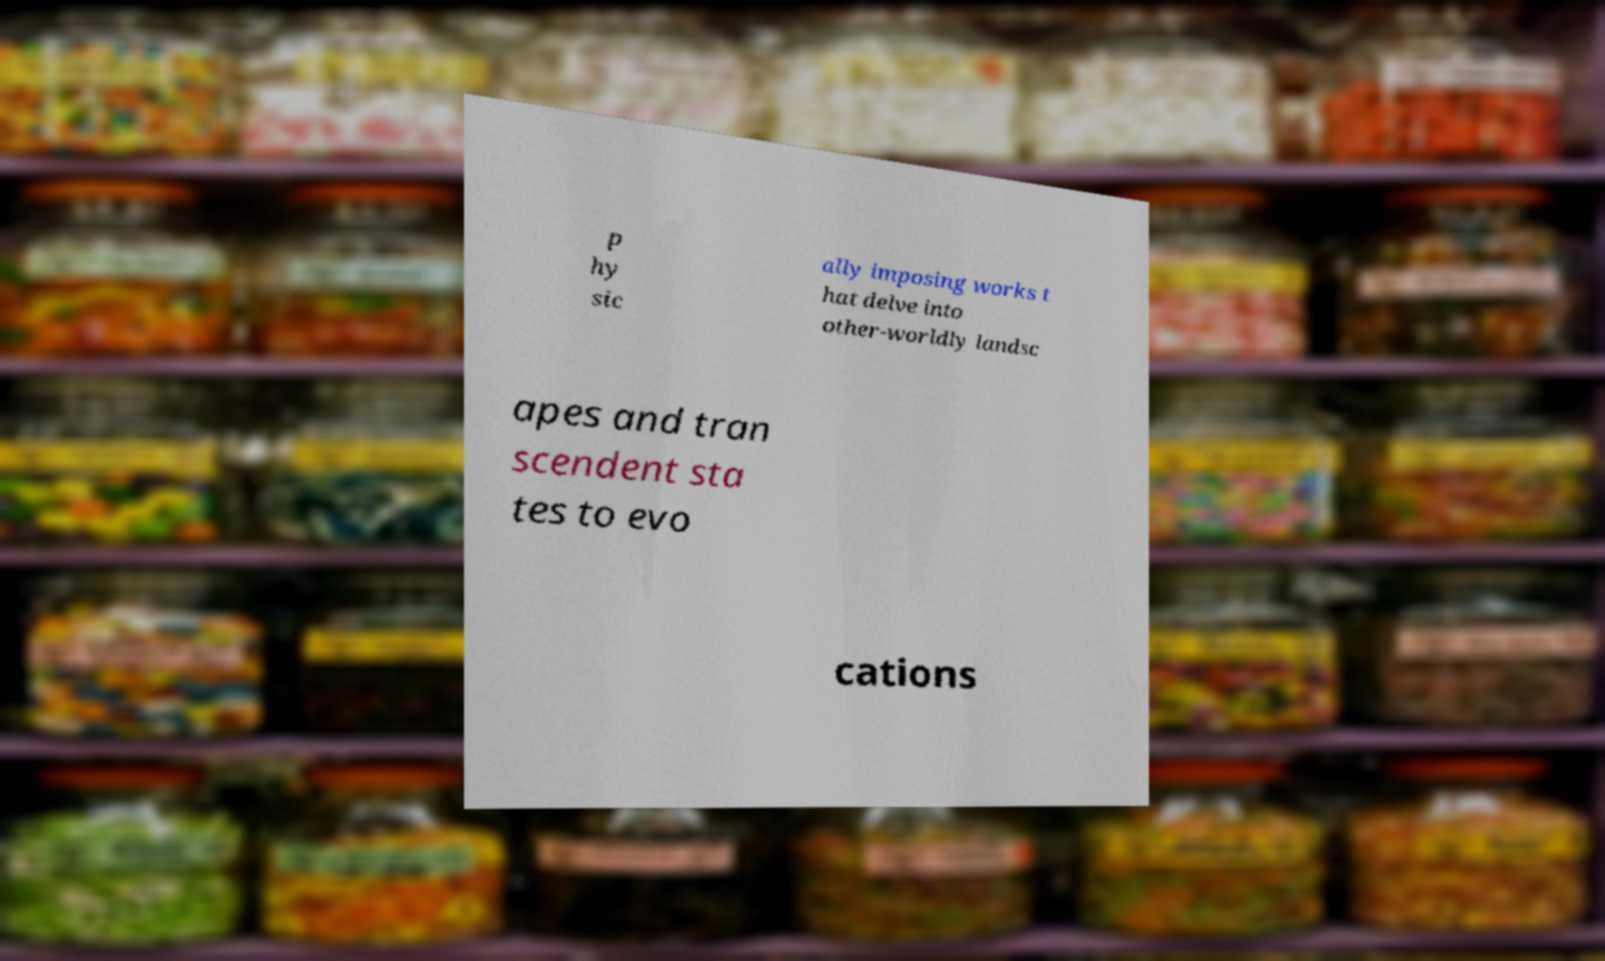There's text embedded in this image that I need extracted. Can you transcribe it verbatim? p hy sic ally imposing works t hat delve into other-worldly landsc apes and tran scendent sta tes to evo cations 